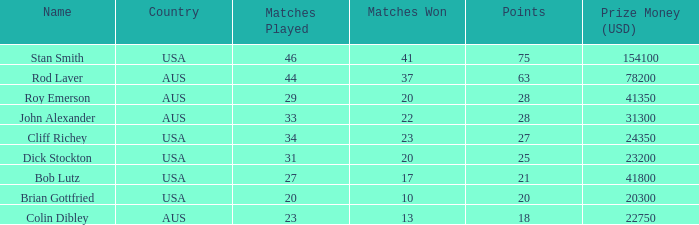I'm looking to parse the entire table for insights. Could you assist me with that? {'header': ['Name', 'Country', 'Matches Played', 'Matches Won', 'Points', 'Prize Money (USD)'], 'rows': [['Stan Smith', 'USA', '46', '41', '75', '154100'], ['Rod Laver', 'AUS', '44', '37', '63', '78200'], ['Roy Emerson', 'AUS', '29', '20', '28', '41350'], ['John Alexander', 'AUS', '33', '22', '28', '31300'], ['Cliff Richey', 'USA', '34', '23', '27', '24350'], ['Dick Stockton', 'USA', '31', '20', '25', '23200'], ['Bob Lutz', 'USA', '27', '17', '21', '41800'], ['Brian Gottfried', 'USA', '20', '10', '20', '20300'], ['Colin Dibley', 'AUS', '23', '13', '18', '22750']]} How many matches did the player that played 23 matches win 13.0. 